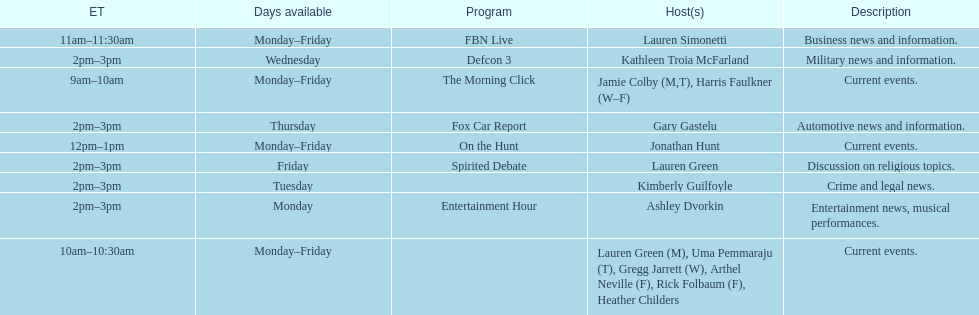Tell me who has her show on fridays at 2. Lauren Green. 